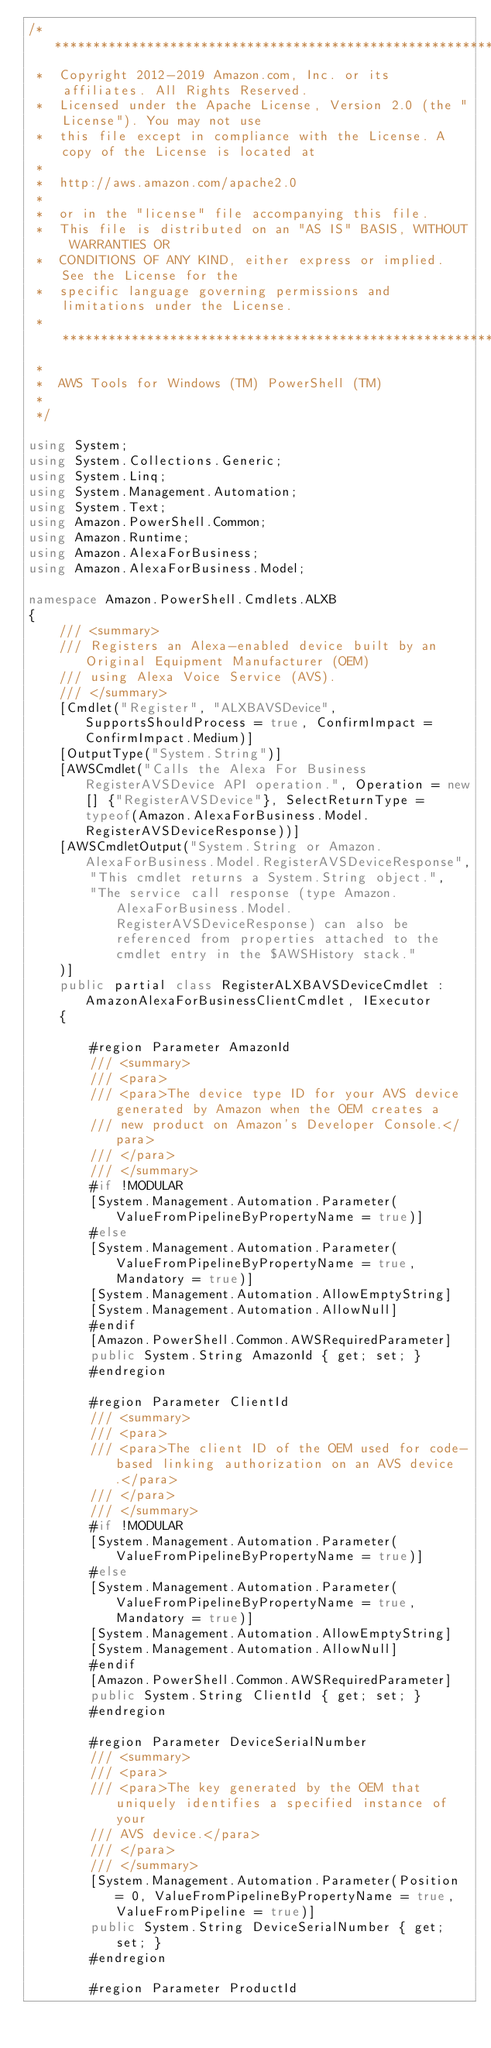Convert code to text. <code><loc_0><loc_0><loc_500><loc_500><_C#_>/*******************************************************************************
 *  Copyright 2012-2019 Amazon.com, Inc. or its affiliates. All Rights Reserved.
 *  Licensed under the Apache License, Version 2.0 (the "License"). You may not use
 *  this file except in compliance with the License. A copy of the License is located at
 *
 *  http://aws.amazon.com/apache2.0
 *
 *  or in the "license" file accompanying this file.
 *  This file is distributed on an "AS IS" BASIS, WITHOUT WARRANTIES OR
 *  CONDITIONS OF ANY KIND, either express or implied. See the License for the
 *  specific language governing permissions and limitations under the License.
 * *****************************************************************************
 *
 *  AWS Tools for Windows (TM) PowerShell (TM)
 *
 */

using System;
using System.Collections.Generic;
using System.Linq;
using System.Management.Automation;
using System.Text;
using Amazon.PowerShell.Common;
using Amazon.Runtime;
using Amazon.AlexaForBusiness;
using Amazon.AlexaForBusiness.Model;

namespace Amazon.PowerShell.Cmdlets.ALXB
{
    /// <summary>
    /// Registers an Alexa-enabled device built by an Original Equipment Manufacturer (OEM)
    /// using Alexa Voice Service (AVS).
    /// </summary>
    [Cmdlet("Register", "ALXBAVSDevice", SupportsShouldProcess = true, ConfirmImpact = ConfirmImpact.Medium)]
    [OutputType("System.String")]
    [AWSCmdlet("Calls the Alexa For Business RegisterAVSDevice API operation.", Operation = new[] {"RegisterAVSDevice"}, SelectReturnType = typeof(Amazon.AlexaForBusiness.Model.RegisterAVSDeviceResponse))]
    [AWSCmdletOutput("System.String or Amazon.AlexaForBusiness.Model.RegisterAVSDeviceResponse",
        "This cmdlet returns a System.String object.",
        "The service call response (type Amazon.AlexaForBusiness.Model.RegisterAVSDeviceResponse) can also be referenced from properties attached to the cmdlet entry in the $AWSHistory stack."
    )]
    public partial class RegisterALXBAVSDeviceCmdlet : AmazonAlexaForBusinessClientCmdlet, IExecutor
    {
        
        #region Parameter AmazonId
        /// <summary>
        /// <para>
        /// <para>The device type ID for your AVS device generated by Amazon when the OEM creates a
        /// new product on Amazon's Developer Console.</para>
        /// </para>
        /// </summary>
        #if !MODULAR
        [System.Management.Automation.Parameter(ValueFromPipelineByPropertyName = true)]
        #else
        [System.Management.Automation.Parameter(ValueFromPipelineByPropertyName = true, Mandatory = true)]
        [System.Management.Automation.AllowEmptyString]
        [System.Management.Automation.AllowNull]
        #endif
        [Amazon.PowerShell.Common.AWSRequiredParameter]
        public System.String AmazonId { get; set; }
        #endregion
        
        #region Parameter ClientId
        /// <summary>
        /// <para>
        /// <para>The client ID of the OEM used for code-based linking authorization on an AVS device.</para>
        /// </para>
        /// </summary>
        #if !MODULAR
        [System.Management.Automation.Parameter(ValueFromPipelineByPropertyName = true)]
        #else
        [System.Management.Automation.Parameter(ValueFromPipelineByPropertyName = true, Mandatory = true)]
        [System.Management.Automation.AllowEmptyString]
        [System.Management.Automation.AllowNull]
        #endif
        [Amazon.PowerShell.Common.AWSRequiredParameter]
        public System.String ClientId { get; set; }
        #endregion
        
        #region Parameter DeviceSerialNumber
        /// <summary>
        /// <para>
        /// <para>The key generated by the OEM that uniquely identifies a specified instance of your
        /// AVS device.</para>
        /// </para>
        /// </summary>
        [System.Management.Automation.Parameter(Position = 0, ValueFromPipelineByPropertyName = true, ValueFromPipeline = true)]
        public System.String DeviceSerialNumber { get; set; }
        #endregion
        
        #region Parameter ProductId</code> 